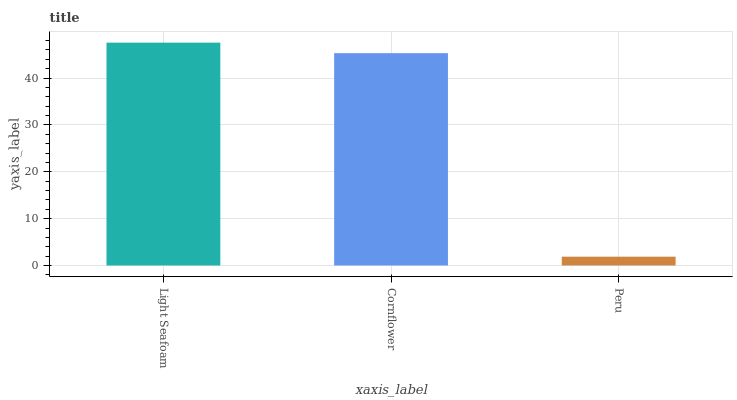Is Cornflower the minimum?
Answer yes or no. No. Is Cornflower the maximum?
Answer yes or no. No. Is Light Seafoam greater than Cornflower?
Answer yes or no. Yes. Is Cornflower less than Light Seafoam?
Answer yes or no. Yes. Is Cornflower greater than Light Seafoam?
Answer yes or no. No. Is Light Seafoam less than Cornflower?
Answer yes or no. No. Is Cornflower the high median?
Answer yes or no. Yes. Is Cornflower the low median?
Answer yes or no. Yes. Is Light Seafoam the high median?
Answer yes or no. No. Is Light Seafoam the low median?
Answer yes or no. No. 